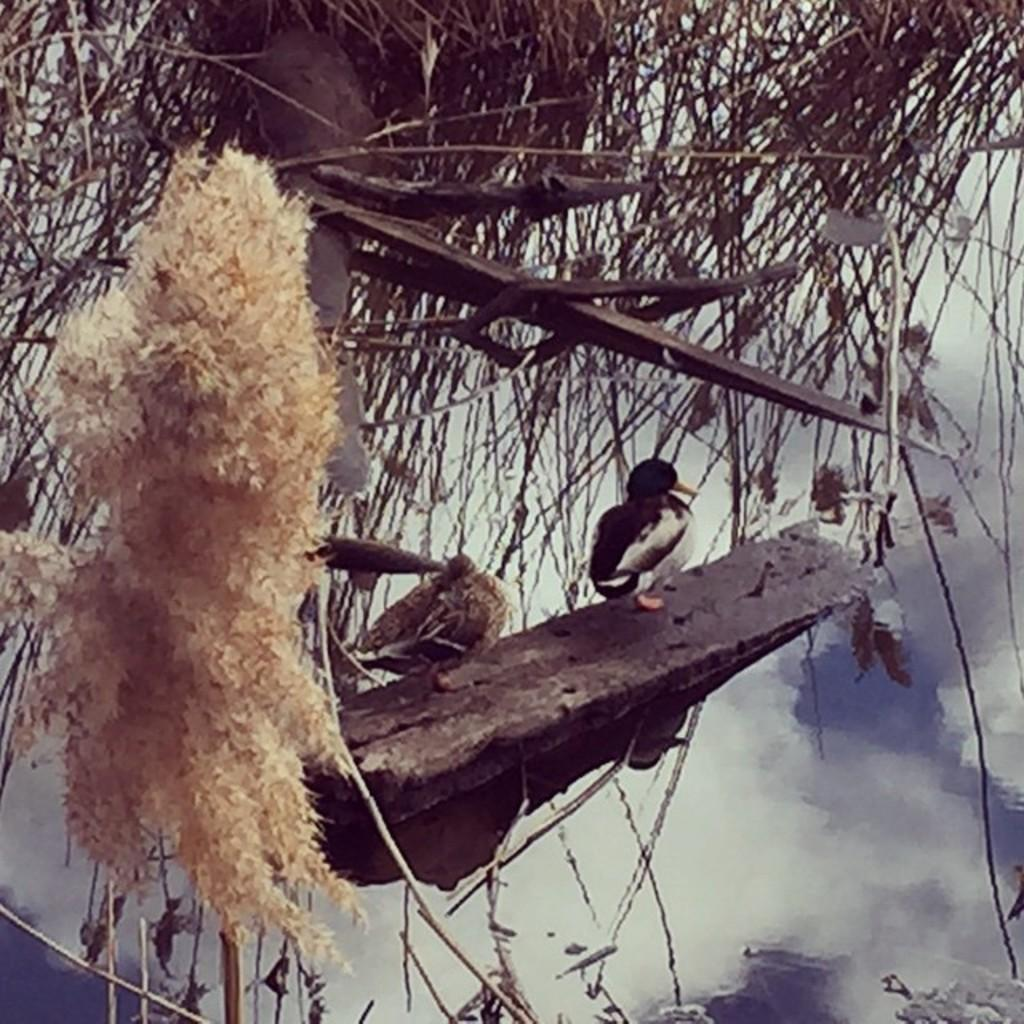How many birds can be seen in the image? There are two birds in the image. What are the birds standing on? The birds are standing on a wooden stick. What type of vegetation is visible at the top of the image? There is grass at the top of the image. Where is the nest located in the image? The nest is on the left side of the image. What can be seen in the sky in the image? Clouds are visible at the bottom of the image. How does the wooden stick fold in the image? The wooden stick does not fold in the image; it is a straight, stationary object. 